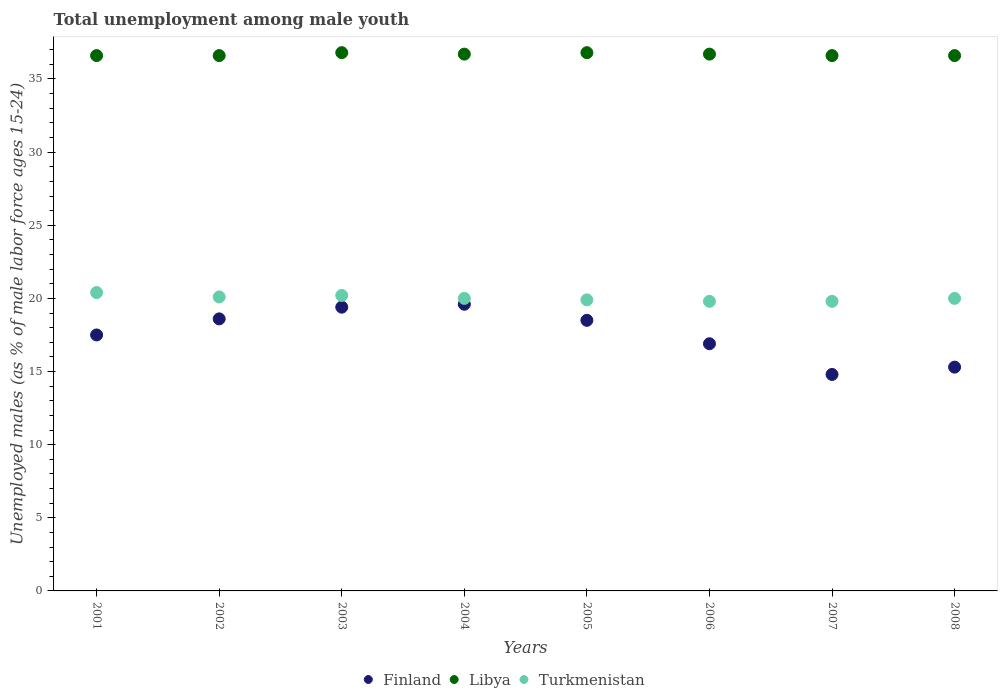How many different coloured dotlines are there?
Your answer should be compact. 3. What is the percentage of unemployed males in in Libya in 2008?
Keep it short and to the point. 36.6. Across all years, what is the maximum percentage of unemployed males in in Finland?
Provide a short and direct response. 19.6. Across all years, what is the minimum percentage of unemployed males in in Finland?
Your answer should be compact. 14.8. In which year was the percentage of unemployed males in in Turkmenistan maximum?
Your response must be concise. 2001. What is the total percentage of unemployed males in in Libya in the graph?
Keep it short and to the point. 293.4. What is the difference between the percentage of unemployed males in in Turkmenistan in 2003 and that in 2006?
Give a very brief answer. 0.4. What is the difference between the percentage of unemployed males in in Finland in 2005 and the percentage of unemployed males in in Libya in 2007?
Offer a terse response. -18.1. What is the average percentage of unemployed males in in Libya per year?
Keep it short and to the point. 36.67. In the year 2001, what is the difference between the percentage of unemployed males in in Finland and percentage of unemployed males in in Libya?
Keep it short and to the point. -19.1. In how many years, is the percentage of unemployed males in in Libya greater than 9 %?
Provide a short and direct response. 8. What is the difference between the highest and the second highest percentage of unemployed males in in Finland?
Keep it short and to the point. 0.2. What is the difference between the highest and the lowest percentage of unemployed males in in Turkmenistan?
Give a very brief answer. 0.6. Is the percentage of unemployed males in in Turkmenistan strictly less than the percentage of unemployed males in in Finland over the years?
Provide a succinct answer. No. How many dotlines are there?
Offer a very short reply. 3. How many years are there in the graph?
Offer a very short reply. 8. What is the difference between two consecutive major ticks on the Y-axis?
Offer a terse response. 5. Does the graph contain any zero values?
Offer a very short reply. No. Does the graph contain grids?
Ensure brevity in your answer.  No. How many legend labels are there?
Give a very brief answer. 3. What is the title of the graph?
Your answer should be compact. Total unemployment among male youth. Does "Togo" appear as one of the legend labels in the graph?
Keep it short and to the point. No. What is the label or title of the X-axis?
Ensure brevity in your answer.  Years. What is the label or title of the Y-axis?
Provide a short and direct response. Unemployed males (as % of male labor force ages 15-24). What is the Unemployed males (as % of male labor force ages 15-24) of Finland in 2001?
Provide a short and direct response. 17.5. What is the Unemployed males (as % of male labor force ages 15-24) of Libya in 2001?
Offer a terse response. 36.6. What is the Unemployed males (as % of male labor force ages 15-24) in Turkmenistan in 2001?
Offer a very short reply. 20.4. What is the Unemployed males (as % of male labor force ages 15-24) in Finland in 2002?
Provide a short and direct response. 18.6. What is the Unemployed males (as % of male labor force ages 15-24) in Libya in 2002?
Keep it short and to the point. 36.6. What is the Unemployed males (as % of male labor force ages 15-24) of Turkmenistan in 2002?
Offer a very short reply. 20.1. What is the Unemployed males (as % of male labor force ages 15-24) of Finland in 2003?
Your answer should be very brief. 19.4. What is the Unemployed males (as % of male labor force ages 15-24) of Libya in 2003?
Provide a short and direct response. 36.8. What is the Unemployed males (as % of male labor force ages 15-24) in Turkmenistan in 2003?
Keep it short and to the point. 20.2. What is the Unemployed males (as % of male labor force ages 15-24) in Finland in 2004?
Ensure brevity in your answer.  19.6. What is the Unemployed males (as % of male labor force ages 15-24) of Libya in 2004?
Make the answer very short. 36.7. What is the Unemployed males (as % of male labor force ages 15-24) of Libya in 2005?
Make the answer very short. 36.8. What is the Unemployed males (as % of male labor force ages 15-24) of Turkmenistan in 2005?
Your answer should be compact. 19.9. What is the Unemployed males (as % of male labor force ages 15-24) of Finland in 2006?
Give a very brief answer. 16.9. What is the Unemployed males (as % of male labor force ages 15-24) in Libya in 2006?
Make the answer very short. 36.7. What is the Unemployed males (as % of male labor force ages 15-24) of Turkmenistan in 2006?
Give a very brief answer. 19.8. What is the Unemployed males (as % of male labor force ages 15-24) in Finland in 2007?
Your answer should be very brief. 14.8. What is the Unemployed males (as % of male labor force ages 15-24) of Libya in 2007?
Ensure brevity in your answer.  36.6. What is the Unemployed males (as % of male labor force ages 15-24) of Turkmenistan in 2007?
Offer a terse response. 19.8. What is the Unemployed males (as % of male labor force ages 15-24) of Finland in 2008?
Provide a short and direct response. 15.3. What is the Unemployed males (as % of male labor force ages 15-24) in Libya in 2008?
Your response must be concise. 36.6. Across all years, what is the maximum Unemployed males (as % of male labor force ages 15-24) of Finland?
Keep it short and to the point. 19.6. Across all years, what is the maximum Unemployed males (as % of male labor force ages 15-24) in Libya?
Offer a very short reply. 36.8. Across all years, what is the maximum Unemployed males (as % of male labor force ages 15-24) of Turkmenistan?
Keep it short and to the point. 20.4. Across all years, what is the minimum Unemployed males (as % of male labor force ages 15-24) of Finland?
Ensure brevity in your answer.  14.8. Across all years, what is the minimum Unemployed males (as % of male labor force ages 15-24) of Libya?
Offer a very short reply. 36.6. Across all years, what is the minimum Unemployed males (as % of male labor force ages 15-24) of Turkmenistan?
Your answer should be compact. 19.8. What is the total Unemployed males (as % of male labor force ages 15-24) of Finland in the graph?
Ensure brevity in your answer.  140.6. What is the total Unemployed males (as % of male labor force ages 15-24) in Libya in the graph?
Keep it short and to the point. 293.4. What is the total Unemployed males (as % of male labor force ages 15-24) in Turkmenistan in the graph?
Your response must be concise. 160.2. What is the difference between the Unemployed males (as % of male labor force ages 15-24) in Finland in 2001 and that in 2002?
Provide a succinct answer. -1.1. What is the difference between the Unemployed males (as % of male labor force ages 15-24) of Finland in 2001 and that in 2003?
Your response must be concise. -1.9. What is the difference between the Unemployed males (as % of male labor force ages 15-24) of Libya in 2001 and that in 2003?
Your response must be concise. -0.2. What is the difference between the Unemployed males (as % of male labor force ages 15-24) of Turkmenistan in 2001 and that in 2003?
Your answer should be very brief. 0.2. What is the difference between the Unemployed males (as % of male labor force ages 15-24) of Libya in 2001 and that in 2004?
Offer a very short reply. -0.1. What is the difference between the Unemployed males (as % of male labor force ages 15-24) of Turkmenistan in 2001 and that in 2004?
Your answer should be compact. 0.4. What is the difference between the Unemployed males (as % of male labor force ages 15-24) in Finland in 2001 and that in 2005?
Offer a terse response. -1. What is the difference between the Unemployed males (as % of male labor force ages 15-24) in Turkmenistan in 2001 and that in 2006?
Provide a short and direct response. 0.6. What is the difference between the Unemployed males (as % of male labor force ages 15-24) of Libya in 2001 and that in 2007?
Offer a terse response. 0. What is the difference between the Unemployed males (as % of male labor force ages 15-24) of Libya in 2001 and that in 2008?
Provide a succinct answer. 0. What is the difference between the Unemployed males (as % of male labor force ages 15-24) of Turkmenistan in 2001 and that in 2008?
Your answer should be very brief. 0.4. What is the difference between the Unemployed males (as % of male labor force ages 15-24) of Turkmenistan in 2002 and that in 2003?
Your answer should be compact. -0.1. What is the difference between the Unemployed males (as % of male labor force ages 15-24) in Libya in 2002 and that in 2004?
Make the answer very short. -0.1. What is the difference between the Unemployed males (as % of male labor force ages 15-24) in Turkmenistan in 2002 and that in 2004?
Your answer should be compact. 0.1. What is the difference between the Unemployed males (as % of male labor force ages 15-24) in Turkmenistan in 2002 and that in 2005?
Provide a short and direct response. 0.2. What is the difference between the Unemployed males (as % of male labor force ages 15-24) of Finland in 2002 and that in 2006?
Give a very brief answer. 1.7. What is the difference between the Unemployed males (as % of male labor force ages 15-24) of Libya in 2002 and that in 2006?
Give a very brief answer. -0.1. What is the difference between the Unemployed males (as % of male labor force ages 15-24) in Libya in 2002 and that in 2007?
Your response must be concise. 0. What is the difference between the Unemployed males (as % of male labor force ages 15-24) in Finland in 2002 and that in 2008?
Offer a terse response. 3.3. What is the difference between the Unemployed males (as % of male labor force ages 15-24) of Libya in 2002 and that in 2008?
Offer a terse response. 0. What is the difference between the Unemployed males (as % of male labor force ages 15-24) in Libya in 2003 and that in 2004?
Provide a succinct answer. 0.1. What is the difference between the Unemployed males (as % of male labor force ages 15-24) in Turkmenistan in 2003 and that in 2005?
Offer a very short reply. 0.3. What is the difference between the Unemployed males (as % of male labor force ages 15-24) of Finland in 2003 and that in 2006?
Provide a succinct answer. 2.5. What is the difference between the Unemployed males (as % of male labor force ages 15-24) in Turkmenistan in 2003 and that in 2006?
Your response must be concise. 0.4. What is the difference between the Unemployed males (as % of male labor force ages 15-24) of Finland in 2003 and that in 2007?
Offer a very short reply. 4.6. What is the difference between the Unemployed males (as % of male labor force ages 15-24) of Libya in 2004 and that in 2005?
Provide a succinct answer. -0.1. What is the difference between the Unemployed males (as % of male labor force ages 15-24) in Libya in 2004 and that in 2006?
Give a very brief answer. 0. What is the difference between the Unemployed males (as % of male labor force ages 15-24) in Finland in 2004 and that in 2007?
Provide a succinct answer. 4.8. What is the difference between the Unemployed males (as % of male labor force ages 15-24) of Finland in 2004 and that in 2008?
Keep it short and to the point. 4.3. What is the difference between the Unemployed males (as % of male labor force ages 15-24) of Turkmenistan in 2004 and that in 2008?
Keep it short and to the point. 0. What is the difference between the Unemployed males (as % of male labor force ages 15-24) in Libya in 2005 and that in 2006?
Provide a succinct answer. 0.1. What is the difference between the Unemployed males (as % of male labor force ages 15-24) of Turkmenistan in 2005 and that in 2006?
Offer a terse response. 0.1. What is the difference between the Unemployed males (as % of male labor force ages 15-24) in Finland in 2005 and that in 2008?
Provide a short and direct response. 3.2. What is the difference between the Unemployed males (as % of male labor force ages 15-24) of Libya in 2005 and that in 2008?
Provide a short and direct response. 0.2. What is the difference between the Unemployed males (as % of male labor force ages 15-24) of Turkmenistan in 2005 and that in 2008?
Ensure brevity in your answer.  -0.1. What is the difference between the Unemployed males (as % of male labor force ages 15-24) in Finland in 2006 and that in 2007?
Keep it short and to the point. 2.1. What is the difference between the Unemployed males (as % of male labor force ages 15-24) in Libya in 2006 and that in 2007?
Your answer should be very brief. 0.1. What is the difference between the Unemployed males (as % of male labor force ages 15-24) of Libya in 2007 and that in 2008?
Your response must be concise. 0. What is the difference between the Unemployed males (as % of male labor force ages 15-24) of Finland in 2001 and the Unemployed males (as % of male labor force ages 15-24) of Libya in 2002?
Provide a short and direct response. -19.1. What is the difference between the Unemployed males (as % of male labor force ages 15-24) in Finland in 2001 and the Unemployed males (as % of male labor force ages 15-24) in Turkmenistan in 2002?
Offer a terse response. -2.6. What is the difference between the Unemployed males (as % of male labor force ages 15-24) of Libya in 2001 and the Unemployed males (as % of male labor force ages 15-24) of Turkmenistan in 2002?
Keep it short and to the point. 16.5. What is the difference between the Unemployed males (as % of male labor force ages 15-24) of Finland in 2001 and the Unemployed males (as % of male labor force ages 15-24) of Libya in 2003?
Make the answer very short. -19.3. What is the difference between the Unemployed males (as % of male labor force ages 15-24) in Finland in 2001 and the Unemployed males (as % of male labor force ages 15-24) in Libya in 2004?
Provide a succinct answer. -19.2. What is the difference between the Unemployed males (as % of male labor force ages 15-24) of Finland in 2001 and the Unemployed males (as % of male labor force ages 15-24) of Turkmenistan in 2004?
Provide a short and direct response. -2.5. What is the difference between the Unemployed males (as % of male labor force ages 15-24) of Libya in 2001 and the Unemployed males (as % of male labor force ages 15-24) of Turkmenistan in 2004?
Make the answer very short. 16.6. What is the difference between the Unemployed males (as % of male labor force ages 15-24) in Finland in 2001 and the Unemployed males (as % of male labor force ages 15-24) in Libya in 2005?
Offer a very short reply. -19.3. What is the difference between the Unemployed males (as % of male labor force ages 15-24) in Finland in 2001 and the Unemployed males (as % of male labor force ages 15-24) in Turkmenistan in 2005?
Your response must be concise. -2.4. What is the difference between the Unemployed males (as % of male labor force ages 15-24) in Libya in 2001 and the Unemployed males (as % of male labor force ages 15-24) in Turkmenistan in 2005?
Provide a succinct answer. 16.7. What is the difference between the Unemployed males (as % of male labor force ages 15-24) of Finland in 2001 and the Unemployed males (as % of male labor force ages 15-24) of Libya in 2006?
Give a very brief answer. -19.2. What is the difference between the Unemployed males (as % of male labor force ages 15-24) in Libya in 2001 and the Unemployed males (as % of male labor force ages 15-24) in Turkmenistan in 2006?
Make the answer very short. 16.8. What is the difference between the Unemployed males (as % of male labor force ages 15-24) in Finland in 2001 and the Unemployed males (as % of male labor force ages 15-24) in Libya in 2007?
Your answer should be compact. -19.1. What is the difference between the Unemployed males (as % of male labor force ages 15-24) of Finland in 2001 and the Unemployed males (as % of male labor force ages 15-24) of Libya in 2008?
Keep it short and to the point. -19.1. What is the difference between the Unemployed males (as % of male labor force ages 15-24) of Finland in 2002 and the Unemployed males (as % of male labor force ages 15-24) of Libya in 2003?
Offer a very short reply. -18.2. What is the difference between the Unemployed males (as % of male labor force ages 15-24) in Finland in 2002 and the Unemployed males (as % of male labor force ages 15-24) in Turkmenistan in 2003?
Provide a succinct answer. -1.6. What is the difference between the Unemployed males (as % of male labor force ages 15-24) of Libya in 2002 and the Unemployed males (as % of male labor force ages 15-24) of Turkmenistan in 2003?
Your answer should be very brief. 16.4. What is the difference between the Unemployed males (as % of male labor force ages 15-24) of Finland in 2002 and the Unemployed males (as % of male labor force ages 15-24) of Libya in 2004?
Your answer should be compact. -18.1. What is the difference between the Unemployed males (as % of male labor force ages 15-24) of Libya in 2002 and the Unemployed males (as % of male labor force ages 15-24) of Turkmenistan in 2004?
Your response must be concise. 16.6. What is the difference between the Unemployed males (as % of male labor force ages 15-24) of Finland in 2002 and the Unemployed males (as % of male labor force ages 15-24) of Libya in 2005?
Your answer should be compact. -18.2. What is the difference between the Unemployed males (as % of male labor force ages 15-24) of Libya in 2002 and the Unemployed males (as % of male labor force ages 15-24) of Turkmenistan in 2005?
Ensure brevity in your answer.  16.7. What is the difference between the Unemployed males (as % of male labor force ages 15-24) of Finland in 2002 and the Unemployed males (as % of male labor force ages 15-24) of Libya in 2006?
Keep it short and to the point. -18.1. What is the difference between the Unemployed males (as % of male labor force ages 15-24) in Finland in 2002 and the Unemployed males (as % of male labor force ages 15-24) in Turkmenistan in 2006?
Give a very brief answer. -1.2. What is the difference between the Unemployed males (as % of male labor force ages 15-24) of Finland in 2002 and the Unemployed males (as % of male labor force ages 15-24) of Libya in 2007?
Your answer should be compact. -18. What is the difference between the Unemployed males (as % of male labor force ages 15-24) in Finland in 2002 and the Unemployed males (as % of male labor force ages 15-24) in Turkmenistan in 2007?
Give a very brief answer. -1.2. What is the difference between the Unemployed males (as % of male labor force ages 15-24) of Finland in 2002 and the Unemployed males (as % of male labor force ages 15-24) of Libya in 2008?
Keep it short and to the point. -18. What is the difference between the Unemployed males (as % of male labor force ages 15-24) of Finland in 2002 and the Unemployed males (as % of male labor force ages 15-24) of Turkmenistan in 2008?
Your answer should be very brief. -1.4. What is the difference between the Unemployed males (as % of male labor force ages 15-24) of Libya in 2002 and the Unemployed males (as % of male labor force ages 15-24) of Turkmenistan in 2008?
Provide a short and direct response. 16.6. What is the difference between the Unemployed males (as % of male labor force ages 15-24) in Finland in 2003 and the Unemployed males (as % of male labor force ages 15-24) in Libya in 2004?
Your response must be concise. -17.3. What is the difference between the Unemployed males (as % of male labor force ages 15-24) in Finland in 2003 and the Unemployed males (as % of male labor force ages 15-24) in Turkmenistan in 2004?
Give a very brief answer. -0.6. What is the difference between the Unemployed males (as % of male labor force ages 15-24) of Libya in 2003 and the Unemployed males (as % of male labor force ages 15-24) of Turkmenistan in 2004?
Offer a terse response. 16.8. What is the difference between the Unemployed males (as % of male labor force ages 15-24) in Finland in 2003 and the Unemployed males (as % of male labor force ages 15-24) in Libya in 2005?
Provide a short and direct response. -17.4. What is the difference between the Unemployed males (as % of male labor force ages 15-24) of Finland in 2003 and the Unemployed males (as % of male labor force ages 15-24) of Turkmenistan in 2005?
Provide a short and direct response. -0.5. What is the difference between the Unemployed males (as % of male labor force ages 15-24) of Finland in 2003 and the Unemployed males (as % of male labor force ages 15-24) of Libya in 2006?
Keep it short and to the point. -17.3. What is the difference between the Unemployed males (as % of male labor force ages 15-24) of Libya in 2003 and the Unemployed males (as % of male labor force ages 15-24) of Turkmenistan in 2006?
Make the answer very short. 17. What is the difference between the Unemployed males (as % of male labor force ages 15-24) in Finland in 2003 and the Unemployed males (as % of male labor force ages 15-24) in Libya in 2007?
Make the answer very short. -17.2. What is the difference between the Unemployed males (as % of male labor force ages 15-24) in Finland in 2003 and the Unemployed males (as % of male labor force ages 15-24) in Libya in 2008?
Give a very brief answer. -17.2. What is the difference between the Unemployed males (as % of male labor force ages 15-24) of Finland in 2004 and the Unemployed males (as % of male labor force ages 15-24) of Libya in 2005?
Provide a short and direct response. -17.2. What is the difference between the Unemployed males (as % of male labor force ages 15-24) of Libya in 2004 and the Unemployed males (as % of male labor force ages 15-24) of Turkmenistan in 2005?
Offer a very short reply. 16.8. What is the difference between the Unemployed males (as % of male labor force ages 15-24) in Finland in 2004 and the Unemployed males (as % of male labor force ages 15-24) in Libya in 2006?
Give a very brief answer. -17.1. What is the difference between the Unemployed males (as % of male labor force ages 15-24) in Libya in 2004 and the Unemployed males (as % of male labor force ages 15-24) in Turkmenistan in 2006?
Your answer should be compact. 16.9. What is the difference between the Unemployed males (as % of male labor force ages 15-24) of Finland in 2004 and the Unemployed males (as % of male labor force ages 15-24) of Libya in 2007?
Keep it short and to the point. -17. What is the difference between the Unemployed males (as % of male labor force ages 15-24) in Libya in 2004 and the Unemployed males (as % of male labor force ages 15-24) in Turkmenistan in 2007?
Offer a very short reply. 16.9. What is the difference between the Unemployed males (as % of male labor force ages 15-24) in Finland in 2004 and the Unemployed males (as % of male labor force ages 15-24) in Libya in 2008?
Provide a succinct answer. -17. What is the difference between the Unemployed males (as % of male labor force ages 15-24) of Finland in 2004 and the Unemployed males (as % of male labor force ages 15-24) of Turkmenistan in 2008?
Your response must be concise. -0.4. What is the difference between the Unemployed males (as % of male labor force ages 15-24) in Libya in 2004 and the Unemployed males (as % of male labor force ages 15-24) in Turkmenistan in 2008?
Ensure brevity in your answer.  16.7. What is the difference between the Unemployed males (as % of male labor force ages 15-24) in Finland in 2005 and the Unemployed males (as % of male labor force ages 15-24) in Libya in 2006?
Ensure brevity in your answer.  -18.2. What is the difference between the Unemployed males (as % of male labor force ages 15-24) in Finland in 2005 and the Unemployed males (as % of male labor force ages 15-24) in Turkmenistan in 2006?
Your response must be concise. -1.3. What is the difference between the Unemployed males (as % of male labor force ages 15-24) in Libya in 2005 and the Unemployed males (as % of male labor force ages 15-24) in Turkmenistan in 2006?
Offer a terse response. 17. What is the difference between the Unemployed males (as % of male labor force ages 15-24) in Finland in 2005 and the Unemployed males (as % of male labor force ages 15-24) in Libya in 2007?
Make the answer very short. -18.1. What is the difference between the Unemployed males (as % of male labor force ages 15-24) of Finland in 2005 and the Unemployed males (as % of male labor force ages 15-24) of Turkmenistan in 2007?
Offer a very short reply. -1.3. What is the difference between the Unemployed males (as % of male labor force ages 15-24) of Finland in 2005 and the Unemployed males (as % of male labor force ages 15-24) of Libya in 2008?
Your answer should be very brief. -18.1. What is the difference between the Unemployed males (as % of male labor force ages 15-24) of Finland in 2006 and the Unemployed males (as % of male labor force ages 15-24) of Libya in 2007?
Provide a short and direct response. -19.7. What is the difference between the Unemployed males (as % of male labor force ages 15-24) in Libya in 2006 and the Unemployed males (as % of male labor force ages 15-24) in Turkmenistan in 2007?
Offer a terse response. 16.9. What is the difference between the Unemployed males (as % of male labor force ages 15-24) of Finland in 2006 and the Unemployed males (as % of male labor force ages 15-24) of Libya in 2008?
Make the answer very short. -19.7. What is the difference between the Unemployed males (as % of male labor force ages 15-24) of Finland in 2006 and the Unemployed males (as % of male labor force ages 15-24) of Turkmenistan in 2008?
Your response must be concise. -3.1. What is the difference between the Unemployed males (as % of male labor force ages 15-24) of Finland in 2007 and the Unemployed males (as % of male labor force ages 15-24) of Libya in 2008?
Offer a terse response. -21.8. What is the difference between the Unemployed males (as % of male labor force ages 15-24) of Libya in 2007 and the Unemployed males (as % of male labor force ages 15-24) of Turkmenistan in 2008?
Keep it short and to the point. 16.6. What is the average Unemployed males (as % of male labor force ages 15-24) in Finland per year?
Your answer should be compact. 17.57. What is the average Unemployed males (as % of male labor force ages 15-24) of Libya per year?
Make the answer very short. 36.67. What is the average Unemployed males (as % of male labor force ages 15-24) in Turkmenistan per year?
Your answer should be very brief. 20.02. In the year 2001, what is the difference between the Unemployed males (as % of male labor force ages 15-24) of Finland and Unemployed males (as % of male labor force ages 15-24) of Libya?
Provide a short and direct response. -19.1. In the year 2001, what is the difference between the Unemployed males (as % of male labor force ages 15-24) of Finland and Unemployed males (as % of male labor force ages 15-24) of Turkmenistan?
Your answer should be very brief. -2.9. In the year 2001, what is the difference between the Unemployed males (as % of male labor force ages 15-24) in Libya and Unemployed males (as % of male labor force ages 15-24) in Turkmenistan?
Provide a succinct answer. 16.2. In the year 2002, what is the difference between the Unemployed males (as % of male labor force ages 15-24) in Finland and Unemployed males (as % of male labor force ages 15-24) in Turkmenistan?
Provide a succinct answer. -1.5. In the year 2003, what is the difference between the Unemployed males (as % of male labor force ages 15-24) in Finland and Unemployed males (as % of male labor force ages 15-24) in Libya?
Make the answer very short. -17.4. In the year 2003, what is the difference between the Unemployed males (as % of male labor force ages 15-24) in Finland and Unemployed males (as % of male labor force ages 15-24) in Turkmenistan?
Your answer should be very brief. -0.8. In the year 2004, what is the difference between the Unemployed males (as % of male labor force ages 15-24) in Finland and Unemployed males (as % of male labor force ages 15-24) in Libya?
Your answer should be compact. -17.1. In the year 2005, what is the difference between the Unemployed males (as % of male labor force ages 15-24) in Finland and Unemployed males (as % of male labor force ages 15-24) in Libya?
Offer a terse response. -18.3. In the year 2006, what is the difference between the Unemployed males (as % of male labor force ages 15-24) in Finland and Unemployed males (as % of male labor force ages 15-24) in Libya?
Offer a very short reply. -19.8. In the year 2007, what is the difference between the Unemployed males (as % of male labor force ages 15-24) of Finland and Unemployed males (as % of male labor force ages 15-24) of Libya?
Keep it short and to the point. -21.8. In the year 2008, what is the difference between the Unemployed males (as % of male labor force ages 15-24) in Finland and Unemployed males (as % of male labor force ages 15-24) in Libya?
Ensure brevity in your answer.  -21.3. In the year 2008, what is the difference between the Unemployed males (as % of male labor force ages 15-24) in Libya and Unemployed males (as % of male labor force ages 15-24) in Turkmenistan?
Provide a short and direct response. 16.6. What is the ratio of the Unemployed males (as % of male labor force ages 15-24) in Finland in 2001 to that in 2002?
Ensure brevity in your answer.  0.94. What is the ratio of the Unemployed males (as % of male labor force ages 15-24) in Libya in 2001 to that in 2002?
Provide a short and direct response. 1. What is the ratio of the Unemployed males (as % of male labor force ages 15-24) in Turkmenistan in 2001 to that in 2002?
Keep it short and to the point. 1.01. What is the ratio of the Unemployed males (as % of male labor force ages 15-24) of Finland in 2001 to that in 2003?
Provide a succinct answer. 0.9. What is the ratio of the Unemployed males (as % of male labor force ages 15-24) of Turkmenistan in 2001 to that in 2003?
Offer a very short reply. 1.01. What is the ratio of the Unemployed males (as % of male labor force ages 15-24) in Finland in 2001 to that in 2004?
Provide a short and direct response. 0.89. What is the ratio of the Unemployed males (as % of male labor force ages 15-24) of Turkmenistan in 2001 to that in 2004?
Offer a terse response. 1.02. What is the ratio of the Unemployed males (as % of male labor force ages 15-24) in Finland in 2001 to that in 2005?
Your answer should be very brief. 0.95. What is the ratio of the Unemployed males (as % of male labor force ages 15-24) of Turkmenistan in 2001 to that in 2005?
Provide a short and direct response. 1.03. What is the ratio of the Unemployed males (as % of male labor force ages 15-24) of Finland in 2001 to that in 2006?
Your answer should be very brief. 1.04. What is the ratio of the Unemployed males (as % of male labor force ages 15-24) in Turkmenistan in 2001 to that in 2006?
Make the answer very short. 1.03. What is the ratio of the Unemployed males (as % of male labor force ages 15-24) of Finland in 2001 to that in 2007?
Make the answer very short. 1.18. What is the ratio of the Unemployed males (as % of male labor force ages 15-24) in Libya in 2001 to that in 2007?
Provide a short and direct response. 1. What is the ratio of the Unemployed males (as % of male labor force ages 15-24) in Turkmenistan in 2001 to that in 2007?
Offer a terse response. 1.03. What is the ratio of the Unemployed males (as % of male labor force ages 15-24) in Finland in 2001 to that in 2008?
Offer a very short reply. 1.14. What is the ratio of the Unemployed males (as % of male labor force ages 15-24) of Turkmenistan in 2001 to that in 2008?
Your answer should be very brief. 1.02. What is the ratio of the Unemployed males (as % of male labor force ages 15-24) in Finland in 2002 to that in 2003?
Give a very brief answer. 0.96. What is the ratio of the Unemployed males (as % of male labor force ages 15-24) of Finland in 2002 to that in 2004?
Make the answer very short. 0.95. What is the ratio of the Unemployed males (as % of male labor force ages 15-24) of Turkmenistan in 2002 to that in 2004?
Your answer should be compact. 1. What is the ratio of the Unemployed males (as % of male labor force ages 15-24) in Finland in 2002 to that in 2005?
Provide a succinct answer. 1.01. What is the ratio of the Unemployed males (as % of male labor force ages 15-24) of Libya in 2002 to that in 2005?
Keep it short and to the point. 0.99. What is the ratio of the Unemployed males (as % of male labor force ages 15-24) of Finland in 2002 to that in 2006?
Ensure brevity in your answer.  1.1. What is the ratio of the Unemployed males (as % of male labor force ages 15-24) in Turkmenistan in 2002 to that in 2006?
Provide a succinct answer. 1.02. What is the ratio of the Unemployed males (as % of male labor force ages 15-24) of Finland in 2002 to that in 2007?
Your answer should be compact. 1.26. What is the ratio of the Unemployed males (as % of male labor force ages 15-24) of Libya in 2002 to that in 2007?
Make the answer very short. 1. What is the ratio of the Unemployed males (as % of male labor force ages 15-24) of Turkmenistan in 2002 to that in 2007?
Your answer should be compact. 1.02. What is the ratio of the Unemployed males (as % of male labor force ages 15-24) in Finland in 2002 to that in 2008?
Offer a very short reply. 1.22. What is the ratio of the Unemployed males (as % of male labor force ages 15-24) in Turkmenistan in 2002 to that in 2008?
Offer a terse response. 1. What is the ratio of the Unemployed males (as % of male labor force ages 15-24) in Finland in 2003 to that in 2004?
Provide a short and direct response. 0.99. What is the ratio of the Unemployed males (as % of male labor force ages 15-24) in Libya in 2003 to that in 2004?
Your answer should be very brief. 1. What is the ratio of the Unemployed males (as % of male labor force ages 15-24) of Finland in 2003 to that in 2005?
Provide a succinct answer. 1.05. What is the ratio of the Unemployed males (as % of male labor force ages 15-24) of Libya in 2003 to that in 2005?
Your answer should be very brief. 1. What is the ratio of the Unemployed males (as % of male labor force ages 15-24) of Turkmenistan in 2003 to that in 2005?
Provide a short and direct response. 1.02. What is the ratio of the Unemployed males (as % of male labor force ages 15-24) in Finland in 2003 to that in 2006?
Your response must be concise. 1.15. What is the ratio of the Unemployed males (as % of male labor force ages 15-24) in Turkmenistan in 2003 to that in 2006?
Ensure brevity in your answer.  1.02. What is the ratio of the Unemployed males (as % of male labor force ages 15-24) in Finland in 2003 to that in 2007?
Offer a terse response. 1.31. What is the ratio of the Unemployed males (as % of male labor force ages 15-24) in Turkmenistan in 2003 to that in 2007?
Offer a very short reply. 1.02. What is the ratio of the Unemployed males (as % of male labor force ages 15-24) in Finland in 2003 to that in 2008?
Your response must be concise. 1.27. What is the ratio of the Unemployed males (as % of male labor force ages 15-24) of Libya in 2003 to that in 2008?
Make the answer very short. 1.01. What is the ratio of the Unemployed males (as % of male labor force ages 15-24) of Turkmenistan in 2003 to that in 2008?
Offer a terse response. 1.01. What is the ratio of the Unemployed males (as % of male labor force ages 15-24) in Finland in 2004 to that in 2005?
Your answer should be compact. 1.06. What is the ratio of the Unemployed males (as % of male labor force ages 15-24) of Finland in 2004 to that in 2006?
Offer a terse response. 1.16. What is the ratio of the Unemployed males (as % of male labor force ages 15-24) of Libya in 2004 to that in 2006?
Your answer should be very brief. 1. What is the ratio of the Unemployed males (as % of male labor force ages 15-24) in Finland in 2004 to that in 2007?
Your answer should be very brief. 1.32. What is the ratio of the Unemployed males (as % of male labor force ages 15-24) in Libya in 2004 to that in 2007?
Your answer should be very brief. 1. What is the ratio of the Unemployed males (as % of male labor force ages 15-24) of Finland in 2004 to that in 2008?
Offer a terse response. 1.28. What is the ratio of the Unemployed males (as % of male labor force ages 15-24) of Libya in 2004 to that in 2008?
Your answer should be very brief. 1. What is the ratio of the Unemployed males (as % of male labor force ages 15-24) in Finland in 2005 to that in 2006?
Offer a very short reply. 1.09. What is the ratio of the Unemployed males (as % of male labor force ages 15-24) in Turkmenistan in 2005 to that in 2006?
Your answer should be compact. 1.01. What is the ratio of the Unemployed males (as % of male labor force ages 15-24) in Turkmenistan in 2005 to that in 2007?
Provide a short and direct response. 1.01. What is the ratio of the Unemployed males (as % of male labor force ages 15-24) in Finland in 2005 to that in 2008?
Your response must be concise. 1.21. What is the ratio of the Unemployed males (as % of male labor force ages 15-24) of Libya in 2005 to that in 2008?
Your response must be concise. 1.01. What is the ratio of the Unemployed males (as % of male labor force ages 15-24) in Finland in 2006 to that in 2007?
Make the answer very short. 1.14. What is the ratio of the Unemployed males (as % of male labor force ages 15-24) in Libya in 2006 to that in 2007?
Give a very brief answer. 1. What is the ratio of the Unemployed males (as % of male labor force ages 15-24) in Turkmenistan in 2006 to that in 2007?
Ensure brevity in your answer.  1. What is the ratio of the Unemployed males (as % of male labor force ages 15-24) in Finland in 2006 to that in 2008?
Provide a succinct answer. 1.1. What is the ratio of the Unemployed males (as % of male labor force ages 15-24) in Libya in 2006 to that in 2008?
Make the answer very short. 1. What is the ratio of the Unemployed males (as % of male labor force ages 15-24) of Finland in 2007 to that in 2008?
Ensure brevity in your answer.  0.97. What is the ratio of the Unemployed males (as % of male labor force ages 15-24) of Libya in 2007 to that in 2008?
Your answer should be compact. 1. What is the difference between the highest and the second highest Unemployed males (as % of male labor force ages 15-24) in Libya?
Keep it short and to the point. 0. What is the difference between the highest and the second highest Unemployed males (as % of male labor force ages 15-24) in Turkmenistan?
Your answer should be compact. 0.2. What is the difference between the highest and the lowest Unemployed males (as % of male labor force ages 15-24) in Finland?
Ensure brevity in your answer.  4.8. What is the difference between the highest and the lowest Unemployed males (as % of male labor force ages 15-24) of Turkmenistan?
Make the answer very short. 0.6. 